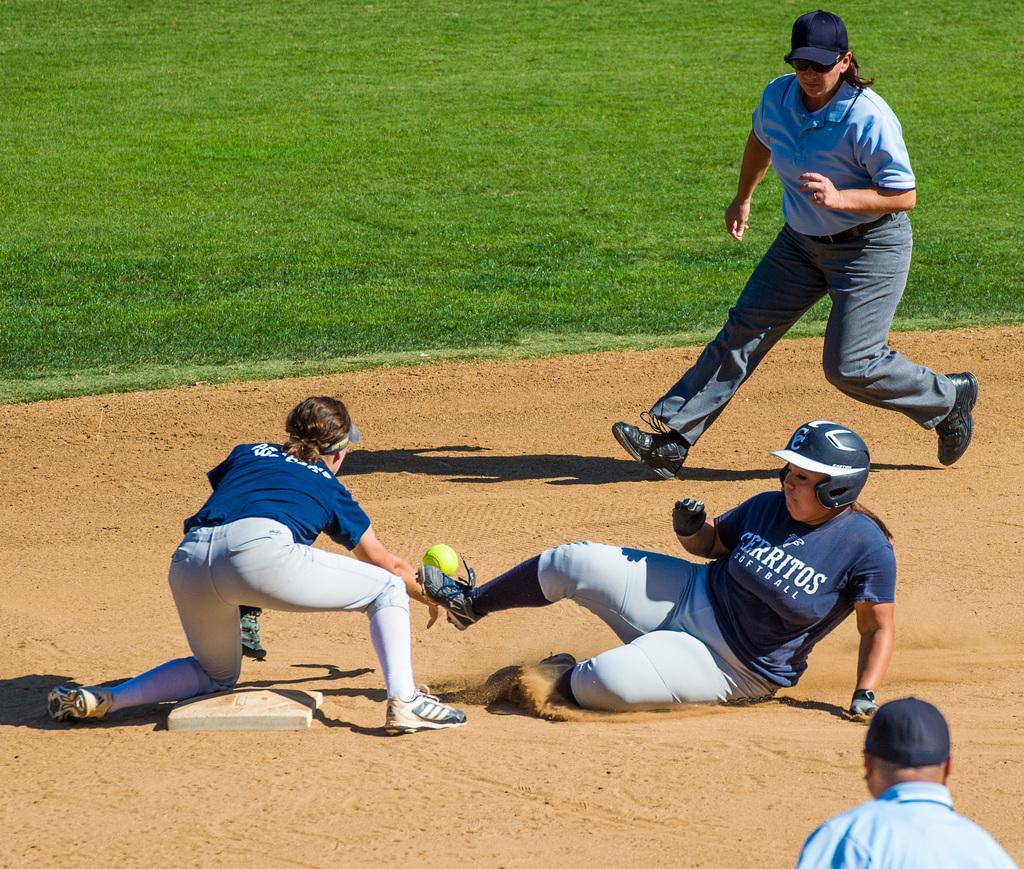Can you describe this image briefly? This is a playing ground. Here I can see four people. Three people are wearing t-shirts, trousers, shoes and playing with a ball on the ground. At the top I can see the grass on the ground. 